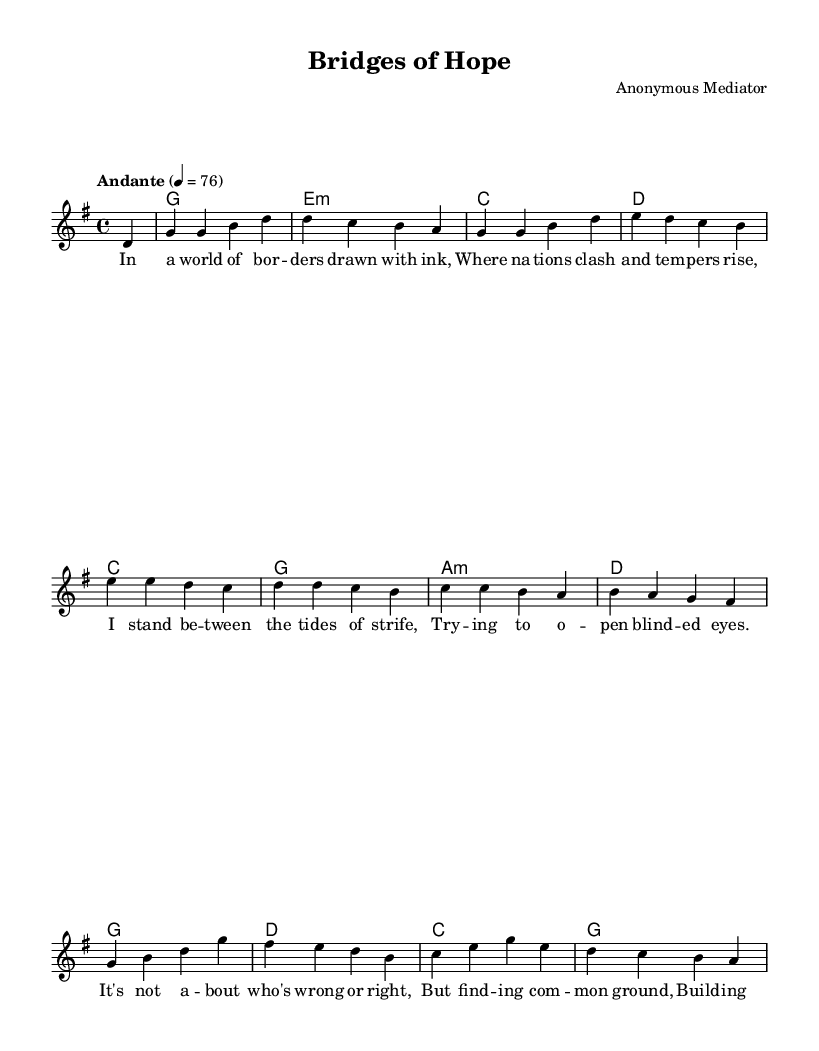What is the key signature of this music? The key signature is G major, which contains one sharp (F#).
Answer: G major What is the time signature of this piece? The time signature is 4/4, indicating four beats per measure.
Answer: 4/4 What is the tempo marking for this music? The tempo marking is Andante, which indicates a moderately slow pace.
Answer: Andante What is the first line of the lyrics? The first line of the lyrics is "In a world of bor -- ders drawn with ink," which sets the theme of division.
Answer: In a world of bor -- ders drawn with ink How many measures are there in the melody section? The melody section contains 8 measures, as inferred from the repeated phrases and the structure of the song.
Answer: 8 In the chorus, what is the first action described? The first action described in the chorus is "Build -- ing brid -- ges o -- ver troub -- led wa -- ters," symbolizing peace and unity.
Answer: Build -- ing brid -- ges o -- ver troub -- led wa -- ters Why is the song titled "Bridges of Hope"? The title reflects the metaphor of building connections and promoting peace, which aligns with the lyrics representing reconciliation and understanding.
Answer: Symbolizes connection and peace 